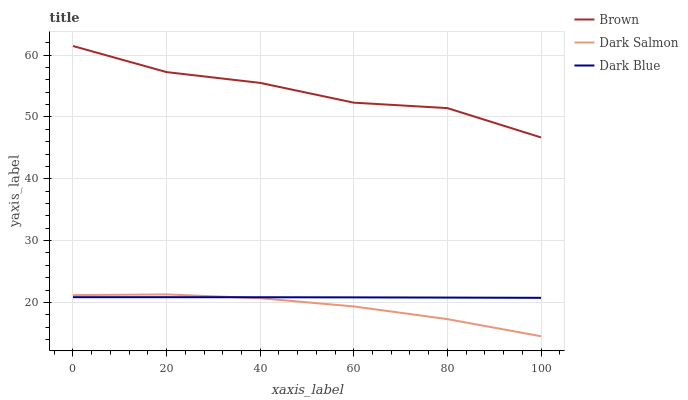Does Dark Blue have the minimum area under the curve?
Answer yes or no. No. Does Dark Blue have the maximum area under the curve?
Answer yes or no. No. Is Dark Salmon the smoothest?
Answer yes or no. No. Is Dark Salmon the roughest?
Answer yes or no. No. Does Dark Blue have the lowest value?
Answer yes or no. No. Does Dark Salmon have the highest value?
Answer yes or no. No. Is Dark Salmon less than Brown?
Answer yes or no. Yes. Is Brown greater than Dark Blue?
Answer yes or no. Yes. Does Dark Salmon intersect Brown?
Answer yes or no. No. 